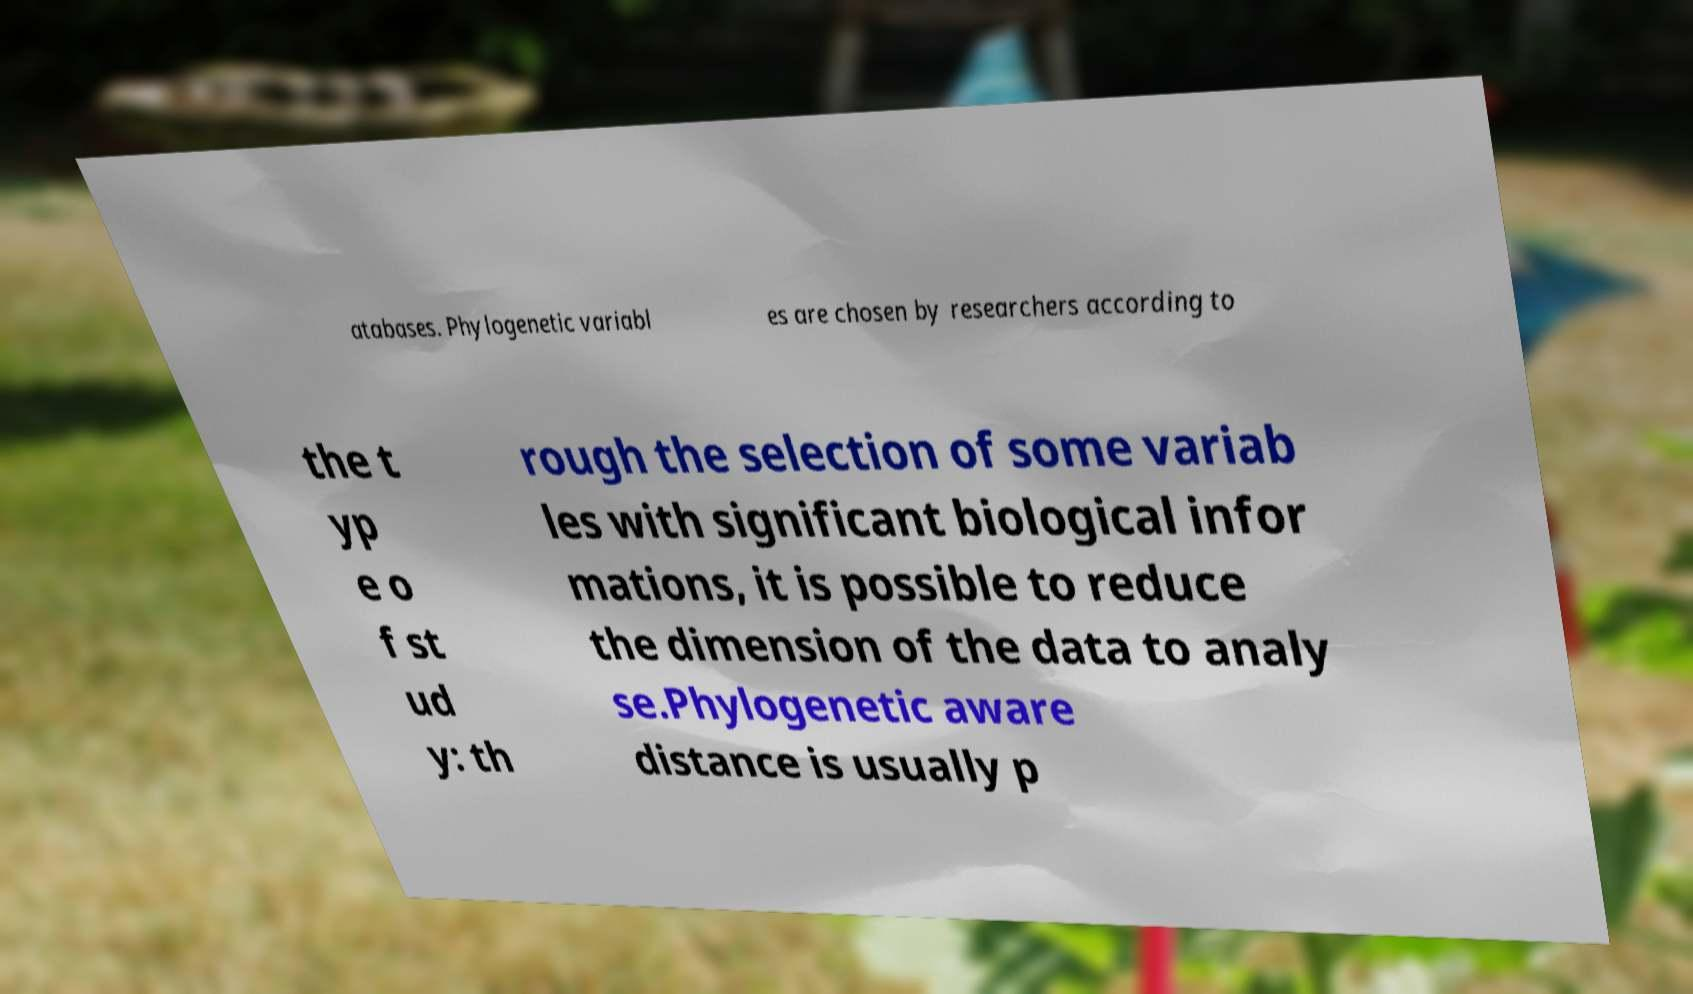Please identify and transcribe the text found in this image. atabases. Phylogenetic variabl es are chosen by researchers according to the t yp e o f st ud y: th rough the selection of some variab les with significant biological infor mations, it is possible to reduce the dimension of the data to analy se.Phylogenetic aware distance is usually p 